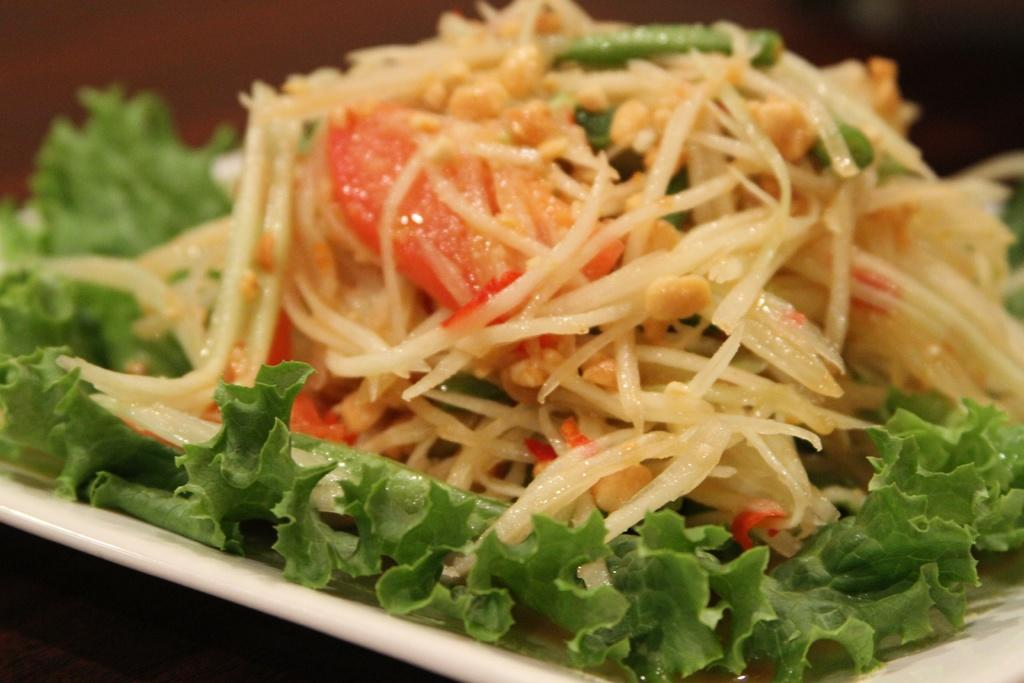What is the main subject of the image? There is a food item in the image. How is the food item presented? The food item is on a plate. Can you describe the background of the image? The background of the image is blurred. What is the income of the toad sitting next to the food item in the image? There is no toad present in the image, and therefore no income can be associated with it. 